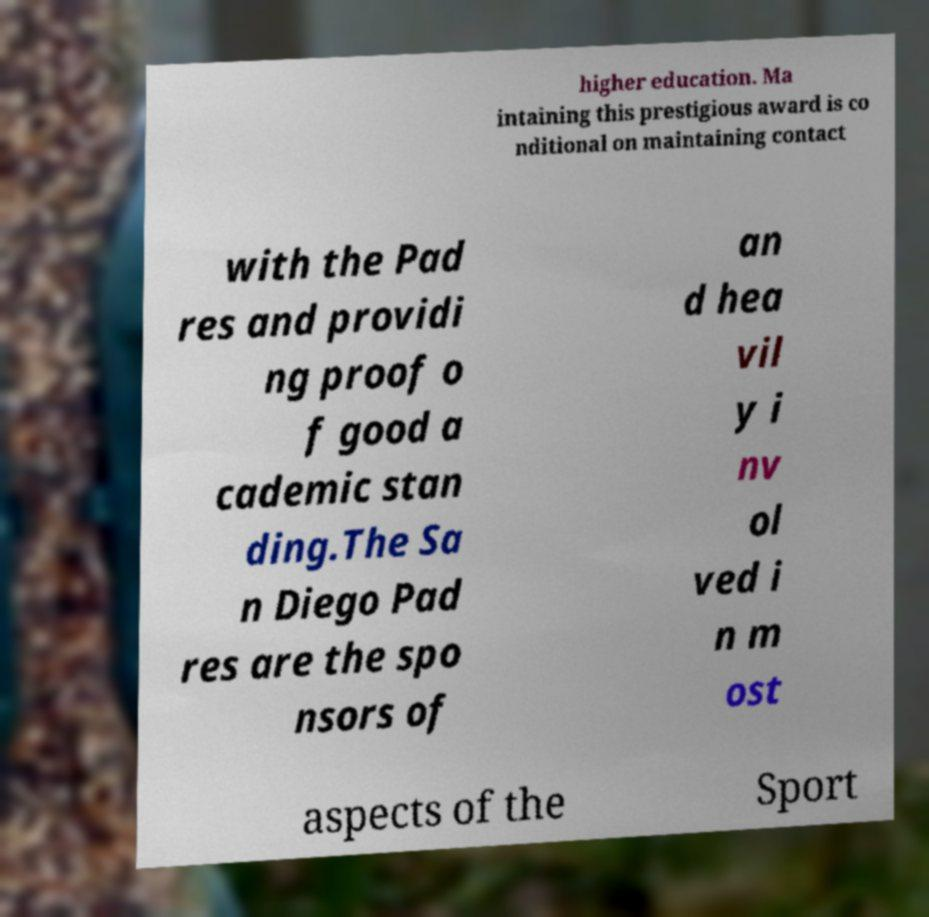Can you accurately transcribe the text from the provided image for me? higher education. Ma intaining this prestigious award is co nditional on maintaining contact with the Pad res and providi ng proof o f good a cademic stan ding.The Sa n Diego Pad res are the spo nsors of an d hea vil y i nv ol ved i n m ost aspects of the Sport 